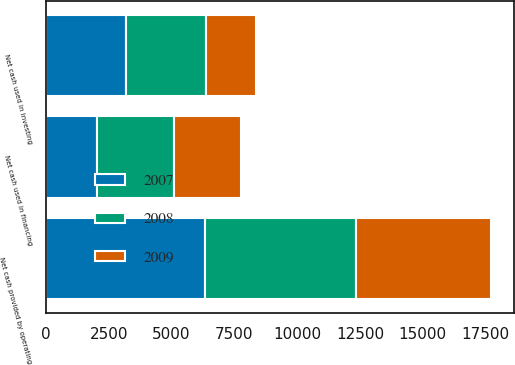Convert chart. <chart><loc_0><loc_0><loc_500><loc_500><stacked_bar_chart><ecel><fcel>Net cash provided by operating<fcel>Net cash used in investing<fcel>Net cash used in financing<nl><fcel>2007<fcel>6336<fcel>3202<fcel>2024<nl><fcel>2008<fcel>5988<fcel>3165<fcel>3073<nl><fcel>2009<fcel>5401<fcel>1992<fcel>2668<nl></chart> 